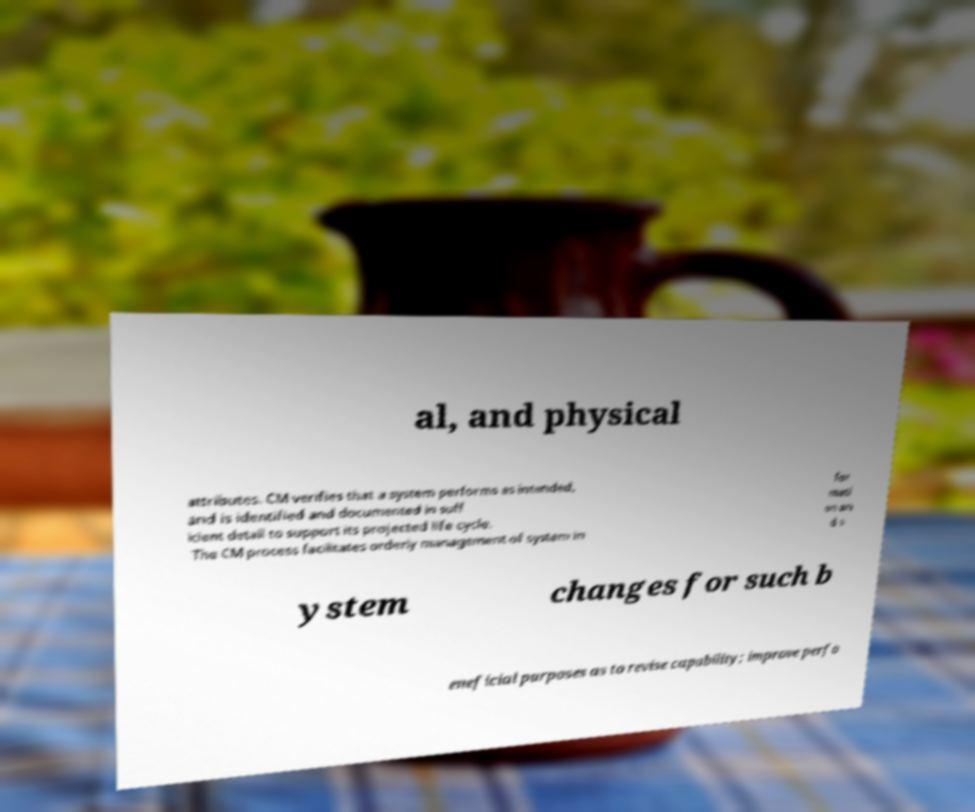Please identify and transcribe the text found in this image. al, and physical attributes. CM verifies that a system performs as intended, and is identified and documented in suff icient detail to support its projected life cycle. The CM process facilitates orderly management of system in for mati on an d s ystem changes for such b eneficial purposes as to revise capability; improve perfo 